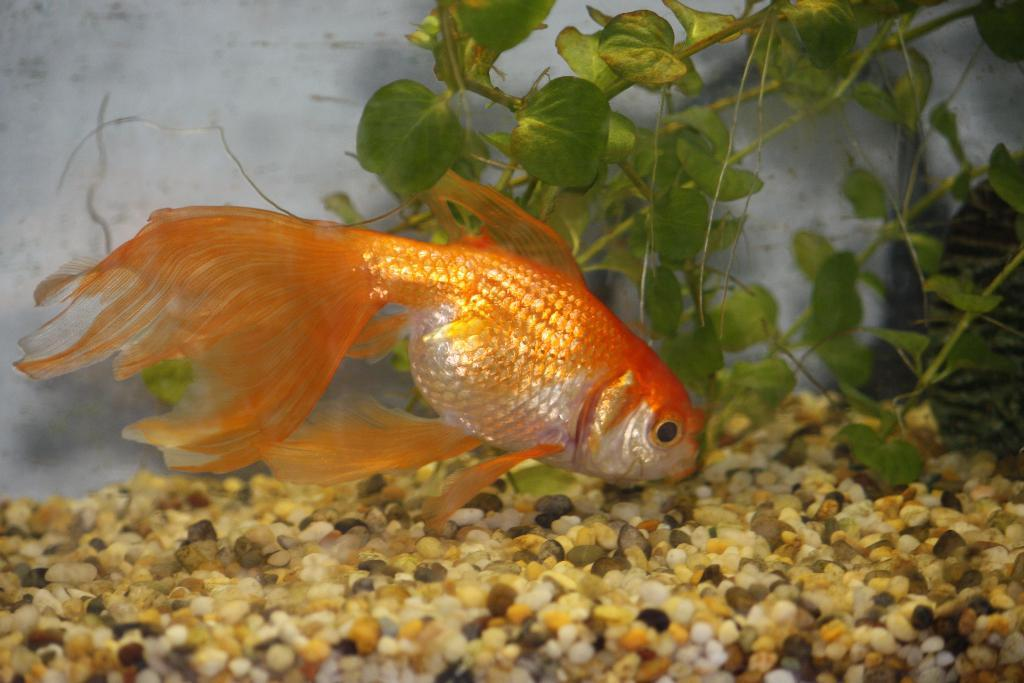What type of animal is in the image? There is a goldfish in the image. What else can be seen in the image besides the goldfish? There are stones in the image. What is visible in the background of the image? There are plants and a white object in the background of the image. What type of gun is being used by the police officer in the image? There are no police officers or guns present in the image; it features a goldfish, stones, and plants in the background. 